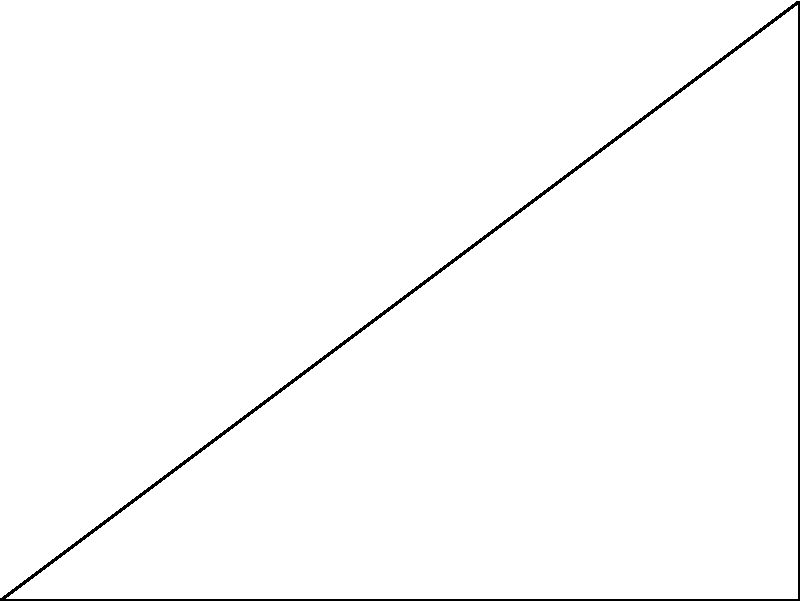On a golf course, you want to determine the direct distance between the tee (point A) and the flag (point C). You know that the fairway runs 80 yards straight from the tee to point B, and from there, it's a 60-yard shot at a right angle to the flag. Using the Pythagorean theorem, calculate the direct distance from the tee to the flag. To solve this problem, we can use the Pythagorean theorem, which states that in a right triangle, the square of the length of the hypotenuse is equal to the sum of squares of the other two sides.

Let's approach this step-by-step:

1) We have a right triangle ABC, where:
   - AB = 80 yards (along the fairway)
   - BC = 60 yards (from fairway to flag)
   - AC = the distance we want to find

2) According to the Pythagorean theorem:
   $AC^2 = AB^2 + BC^2$

3) Substituting the known values:
   $AC^2 = 80^2 + 60^2$

4) Simplify:
   $AC^2 = 6400 + 3600 = 10000$

5) Take the square root of both sides:
   $AC = \sqrt{10000} = 100$

Therefore, the direct distance from the tee to the flag is 100 yards.
Answer: 100 yards 